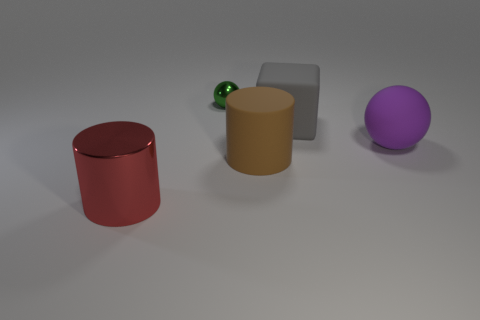Subtract 1 brown cylinders. How many objects are left? 4 Subtract all cubes. How many objects are left? 4 Subtract all green cubes. Subtract all green balls. How many cubes are left? 1 Subtract all gray cubes. How many blue balls are left? 0 Subtract all purple cylinders. Subtract all green metal objects. How many objects are left? 4 Add 4 rubber spheres. How many rubber spheres are left? 5 Add 3 gray metal cubes. How many gray metal cubes exist? 3 Add 2 large yellow cylinders. How many objects exist? 7 Subtract all brown cylinders. How many cylinders are left? 1 